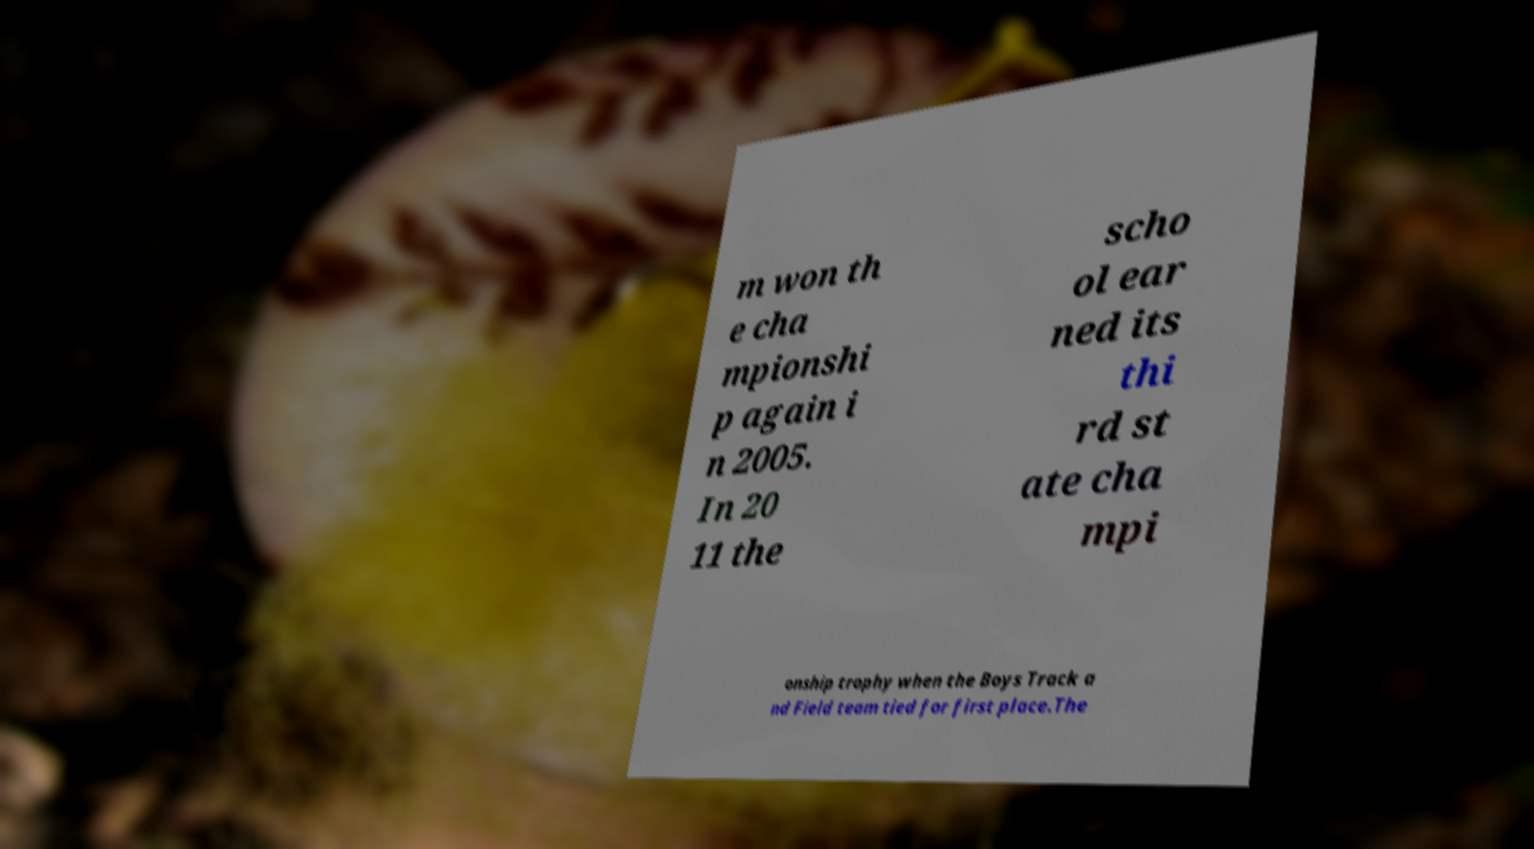Can you read and provide the text displayed in the image?This photo seems to have some interesting text. Can you extract and type it out for me? m won th e cha mpionshi p again i n 2005. In 20 11 the scho ol ear ned its thi rd st ate cha mpi onship trophy when the Boys Track a nd Field team tied for first place.The 